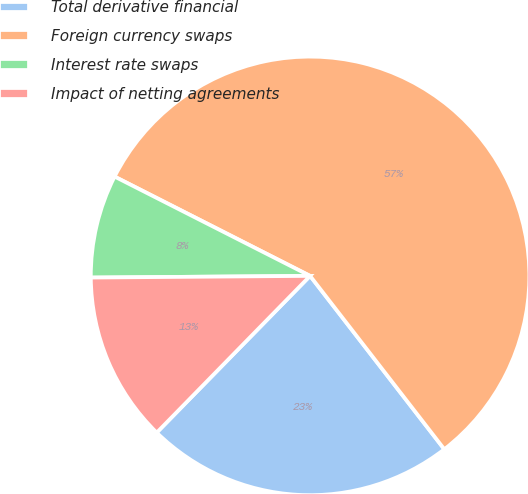Convert chart to OTSL. <chart><loc_0><loc_0><loc_500><loc_500><pie_chart><fcel>Total derivative financial<fcel>Foreign currency swaps<fcel>Interest rate swaps<fcel>Impact of netting agreements<nl><fcel>22.81%<fcel>57.03%<fcel>7.6%<fcel>12.55%<nl></chart> 